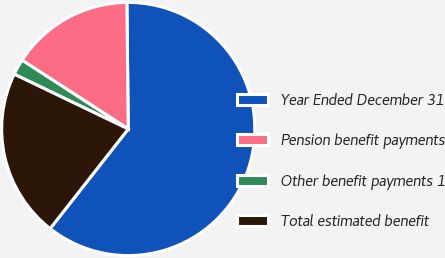Convert chart. <chart><loc_0><loc_0><loc_500><loc_500><pie_chart><fcel>Year Ended December 31<fcel>Pension benefit payments<fcel>Other benefit payments 1<fcel>Total estimated benefit<nl><fcel>60.75%<fcel>15.68%<fcel>2.02%<fcel>21.55%<nl></chart> 